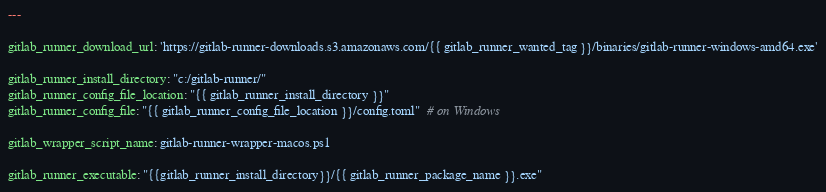Convert code to text. <code><loc_0><loc_0><loc_500><loc_500><_YAML_>---

gitlab_runner_download_url: 'https://gitlab-runner-downloads.s3.amazonaws.com/{{ gitlab_runner_wanted_tag }}/binaries/gitlab-runner-windows-amd64.exe'

gitlab_runner_install_directory: "c:/gitlab-runner/"
gitlab_runner_config_file_location: "{{ gitlab_runner_install_directory }}"
gitlab_runner_config_file: "{{ gitlab_runner_config_file_location }}/config.toml"  # on Windows

gitlab_wrapper_script_name: gitlab-runner-wrapper-macos.ps1

gitlab_runner_executable: "{{gitlab_runner_install_directory}}/{{ gitlab_runner_package_name }}.exe"</code> 